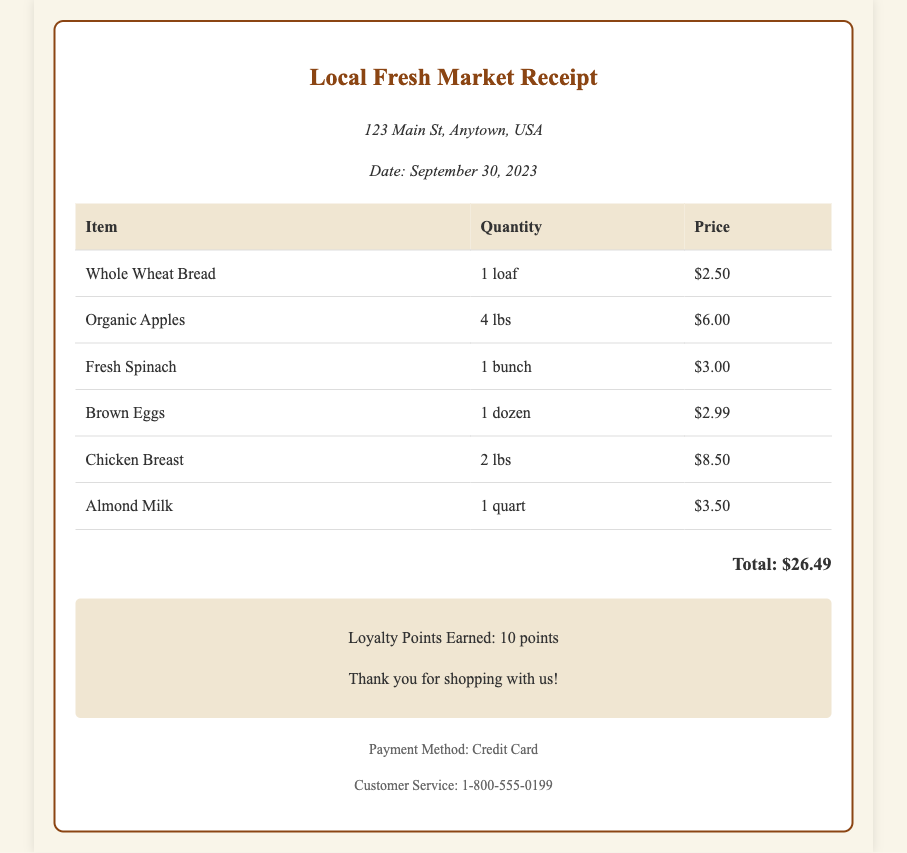What is the date of the receipt? The date on the receipt is specifically mentioned below the store information section.
Answer: September 30, 2023 What is the name of the store? The header of the receipt clearly states the name of the store, which is displayed prominently.
Answer: Local Fresh Market How much did the Whole Wheat Bread cost? Each item's price is listed in the price column next to the item name.
Answer: $2.50 How many pounds of Organic Apples were purchased? The quantity of Organic Apples is provided in the quantity column of the receipt.
Answer: 4 lbs What is the total amount spent on groceries? The total is summed up and shown at the bottom of the receipt.
Answer: $26.49 How many loyalty points were earned? The loyalty points earned are noted in the loyalty section of the document.
Answer: 10 points What payment method was used? The payment method is indicated in the footer of the receipt.
Answer: Credit Card How many items were purchased in total? The total number of rows in the items table indicates the quantity of different items purchased.
Answer: 6 items What type of eggs were bought? The item description provides details about the product, specifically referring to its type.
Answer: Brown Eggs 